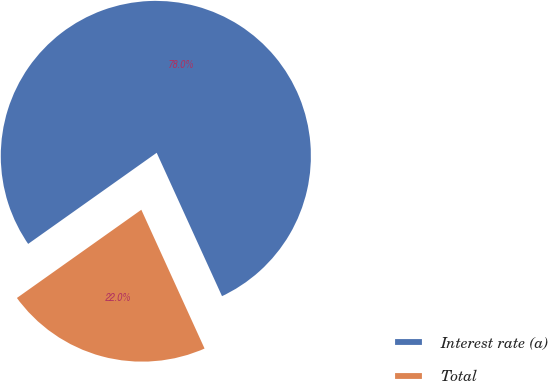Convert chart to OTSL. <chart><loc_0><loc_0><loc_500><loc_500><pie_chart><fcel>Interest rate (a)<fcel>Total<nl><fcel>78.01%<fcel>21.99%<nl></chart> 